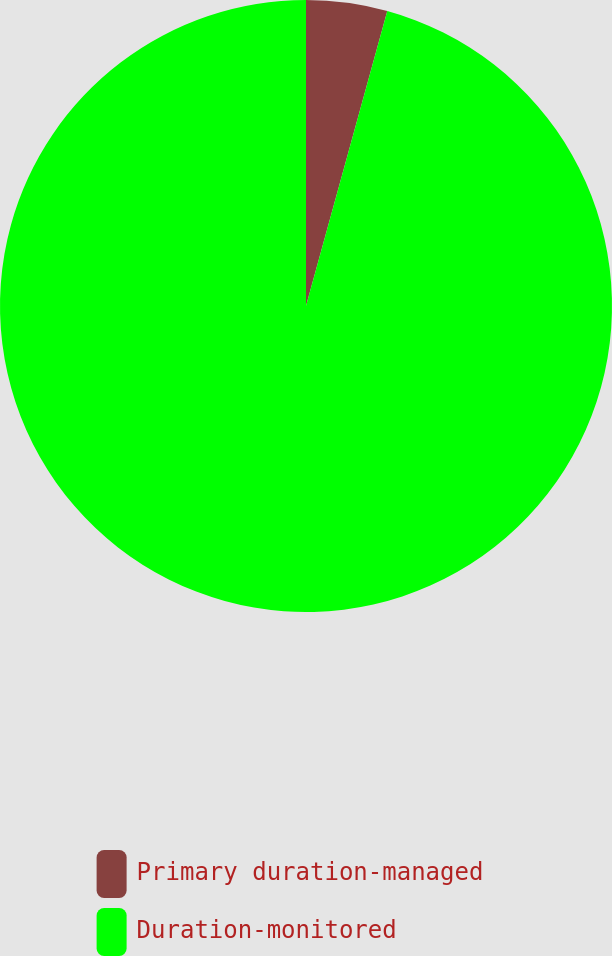Convert chart to OTSL. <chart><loc_0><loc_0><loc_500><loc_500><pie_chart><fcel>Primary duration-managed<fcel>Duration-monitored<nl><fcel>4.28%<fcel>95.72%<nl></chart> 